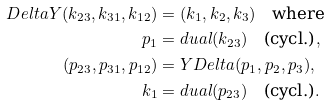<formula> <loc_0><loc_0><loc_500><loc_500>D e l t a Y ( k _ { 2 3 } , k _ { 3 1 } , k _ { 1 2 } ) & = ( k _ { 1 } , k _ { 2 } , k _ { 3 } ) \quad \text {where} \\ p _ { 1 } & = d u a l ( k _ { 2 3 } ) \quad \text {(cycl.)} , \\ ( p _ { 2 3 } , p _ { 3 1 } , p _ { 1 2 } ) & = Y D e l t a ( p _ { 1 } , p _ { 2 } , p _ { 3 } ) , \\ k _ { 1 } & = d u a l ( p _ { 2 3 } ) \quad \text {(cycl.)} .</formula> 